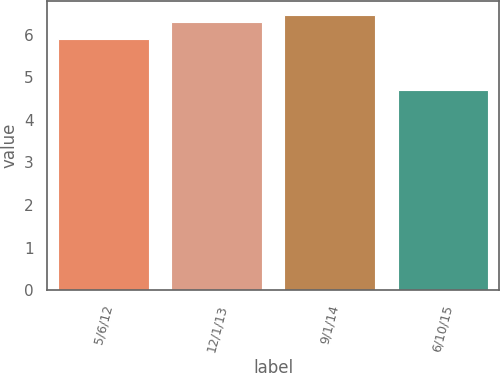Convert chart to OTSL. <chart><loc_0><loc_0><loc_500><loc_500><bar_chart><fcel>5/6/12<fcel>12/1/13<fcel>9/1/14<fcel>6/10/15<nl><fcel>5.9<fcel>6.3<fcel>6.46<fcel>4.7<nl></chart> 